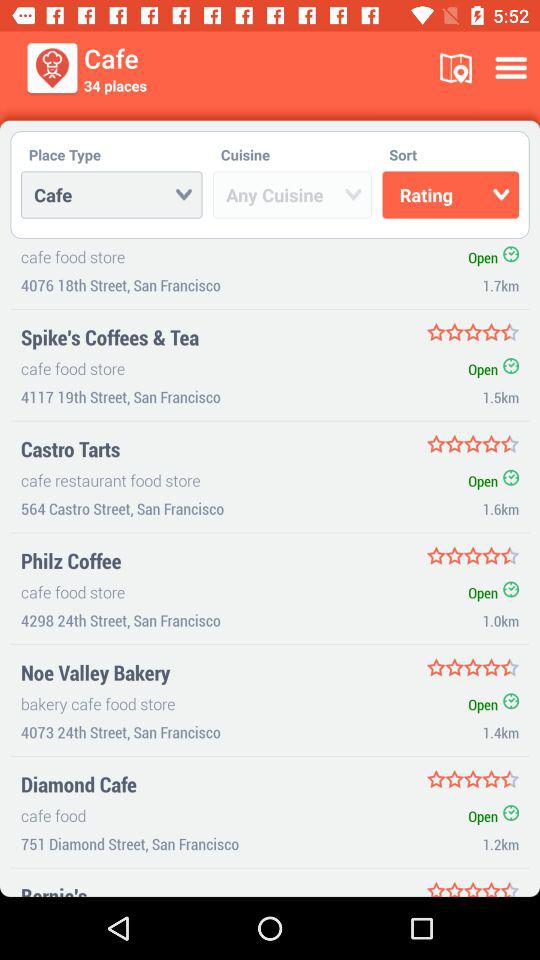What is the distance to "Castro Tarts"? The distance to "Castro Tarts" is 1.6 km. 